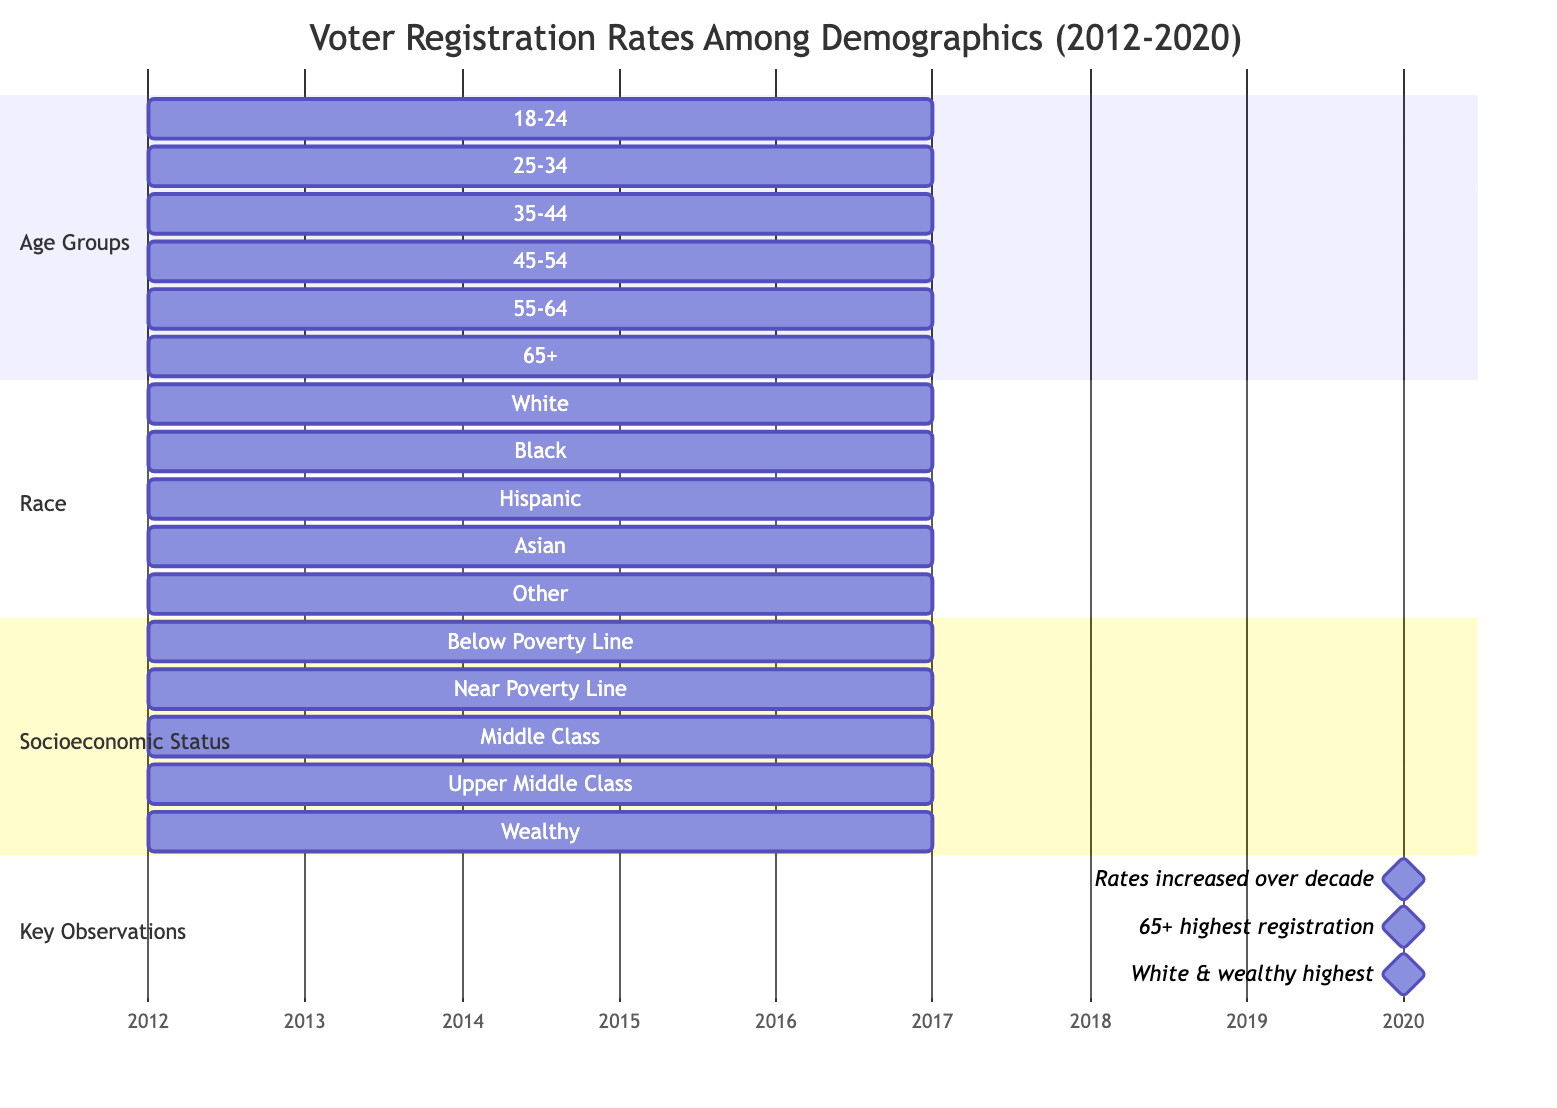What is the voter registration rate for the 18-24 age group in 2020? The diagram shows that the voter registration rate for the 18-24 age group was 45 in 2012 and increased to 50 by 2020.
Answer: 50 Which demographic has the highest voter registration rate in 2020? The diagram indicates that the demographic group aged 65 and above has the highest registration rate, which was noted as 80 in 2020.
Answer: 65+ What was the voter registration rate for Hispanic individuals in 2012? According to the diagram, the voter registration rate for Hispanic individuals in 2012 was indicated as 50.
Answer: 50 How many demographic sections are represented in the diagram? The diagram has three sections: Age Groups, Race, and Socioeconomic Status, totaling three sections represented.
Answer: 3 What is the voter registration rate for individuals below the poverty line in 2020? The diagram specifies that the voter registration rate for those below the poverty line was 40 in 2012 and did not reach a significant increase within the decade.
Answer: 40 Which age group shows the least increase in voter registration rates over the decade? The diagram indicates that the 18-24 age group had the lowest registration rate with only a slight increase from 45 to 50 over the 2012-2020 period.
Answer: 18-24 What is the combined voter registration rate of the white and wealthy groups in 2020? From the diagram, the voter registration rate for the white group in 2020 is 70 and for the wealthy group it is 85, making the total combined rate 155 when added together.
Answer: 155 Which demographic group had a voter registration rate equal to 60 in 2012? The diagram shows that the Black demographic group had a voter registration rate of 60 in 2012.
Answer: Black In which year does the diagram show a milestone for registration rates increasing? The diagram specifies a milestone indicating that rates increased over the decade, noted in the year 2020.
Answer: 2020 